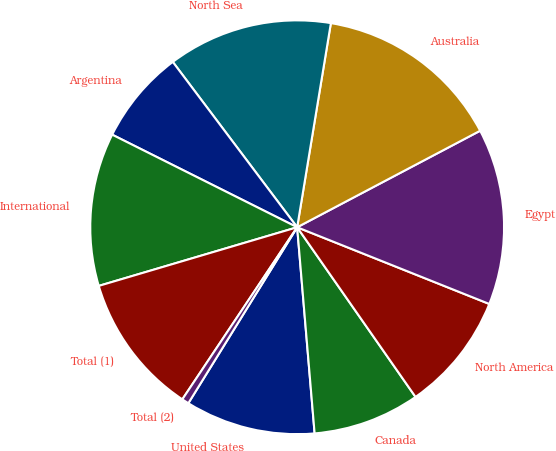<chart> <loc_0><loc_0><loc_500><loc_500><pie_chart><fcel>United States<fcel>Canada<fcel>North America<fcel>Egypt<fcel>Australia<fcel>North Sea<fcel>Argentina<fcel>International<fcel>Total (1)<fcel>Total (2)<nl><fcel>10.16%<fcel>8.35%<fcel>9.26%<fcel>13.77%<fcel>14.67%<fcel>12.87%<fcel>7.35%<fcel>11.96%<fcel>11.06%<fcel>0.55%<nl></chart> 